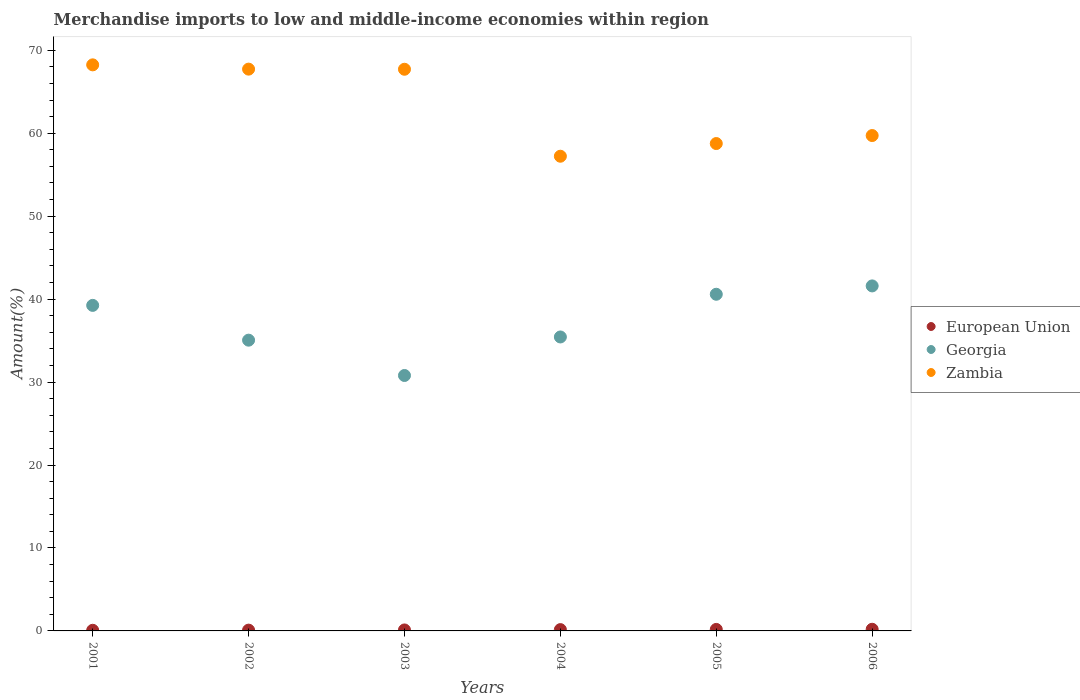Is the number of dotlines equal to the number of legend labels?
Your response must be concise. Yes. What is the percentage of amount earned from merchandise imports in Georgia in 2002?
Offer a terse response. 35.05. Across all years, what is the maximum percentage of amount earned from merchandise imports in Zambia?
Keep it short and to the point. 68.24. Across all years, what is the minimum percentage of amount earned from merchandise imports in Georgia?
Your answer should be compact. 30.79. In which year was the percentage of amount earned from merchandise imports in Georgia maximum?
Ensure brevity in your answer.  2006. What is the total percentage of amount earned from merchandise imports in European Union in the graph?
Keep it short and to the point. 0.83. What is the difference between the percentage of amount earned from merchandise imports in European Union in 2002 and that in 2004?
Provide a succinct answer. -0.06. What is the difference between the percentage of amount earned from merchandise imports in European Union in 2006 and the percentage of amount earned from merchandise imports in Zambia in 2004?
Keep it short and to the point. -57.02. What is the average percentage of amount earned from merchandise imports in Zambia per year?
Give a very brief answer. 63.23. In the year 2002, what is the difference between the percentage of amount earned from merchandise imports in Georgia and percentage of amount earned from merchandise imports in European Union?
Make the answer very short. 34.95. What is the ratio of the percentage of amount earned from merchandise imports in European Union in 2002 to that in 2005?
Offer a very short reply. 0.53. Is the difference between the percentage of amount earned from merchandise imports in Georgia in 2003 and 2005 greater than the difference between the percentage of amount earned from merchandise imports in European Union in 2003 and 2005?
Provide a short and direct response. No. What is the difference between the highest and the second highest percentage of amount earned from merchandise imports in Georgia?
Keep it short and to the point. 1.01. What is the difference between the highest and the lowest percentage of amount earned from merchandise imports in Zambia?
Give a very brief answer. 11.02. In how many years, is the percentage of amount earned from merchandise imports in European Union greater than the average percentage of amount earned from merchandise imports in European Union taken over all years?
Provide a short and direct response. 3. Is the sum of the percentage of amount earned from merchandise imports in Georgia in 2002 and 2006 greater than the maximum percentage of amount earned from merchandise imports in European Union across all years?
Make the answer very short. Yes. Is it the case that in every year, the sum of the percentage of amount earned from merchandise imports in Zambia and percentage of amount earned from merchandise imports in European Union  is greater than the percentage of amount earned from merchandise imports in Georgia?
Provide a short and direct response. Yes. How many dotlines are there?
Your answer should be very brief. 3. How many years are there in the graph?
Offer a very short reply. 6. What is the difference between two consecutive major ticks on the Y-axis?
Keep it short and to the point. 10. Does the graph contain any zero values?
Ensure brevity in your answer.  No. Does the graph contain grids?
Your response must be concise. No. How many legend labels are there?
Make the answer very short. 3. How are the legend labels stacked?
Ensure brevity in your answer.  Vertical. What is the title of the graph?
Keep it short and to the point. Merchandise imports to low and middle-income economies within region. What is the label or title of the X-axis?
Offer a terse response. Years. What is the label or title of the Y-axis?
Make the answer very short. Amount(%). What is the Amount(%) in European Union in 2001?
Offer a very short reply. 0.08. What is the Amount(%) of Georgia in 2001?
Your answer should be compact. 39.24. What is the Amount(%) in Zambia in 2001?
Make the answer very short. 68.24. What is the Amount(%) of European Union in 2002?
Ensure brevity in your answer.  0.1. What is the Amount(%) of Georgia in 2002?
Your answer should be compact. 35.05. What is the Amount(%) of Zambia in 2002?
Give a very brief answer. 67.72. What is the Amount(%) in European Union in 2003?
Make the answer very short. 0.12. What is the Amount(%) in Georgia in 2003?
Ensure brevity in your answer.  30.79. What is the Amount(%) in Zambia in 2003?
Your answer should be compact. 67.71. What is the Amount(%) of European Union in 2004?
Keep it short and to the point. 0.16. What is the Amount(%) in Georgia in 2004?
Offer a very short reply. 35.44. What is the Amount(%) of Zambia in 2004?
Provide a succinct answer. 57.22. What is the Amount(%) of European Union in 2005?
Provide a short and direct response. 0.18. What is the Amount(%) in Georgia in 2005?
Make the answer very short. 40.58. What is the Amount(%) of Zambia in 2005?
Make the answer very short. 58.75. What is the Amount(%) of European Union in 2006?
Keep it short and to the point. 0.2. What is the Amount(%) of Georgia in 2006?
Make the answer very short. 41.59. What is the Amount(%) in Zambia in 2006?
Provide a short and direct response. 59.72. Across all years, what is the maximum Amount(%) of European Union?
Give a very brief answer. 0.2. Across all years, what is the maximum Amount(%) of Georgia?
Make the answer very short. 41.59. Across all years, what is the maximum Amount(%) in Zambia?
Your answer should be compact. 68.24. Across all years, what is the minimum Amount(%) of European Union?
Keep it short and to the point. 0.08. Across all years, what is the minimum Amount(%) in Georgia?
Your response must be concise. 30.79. Across all years, what is the minimum Amount(%) in Zambia?
Keep it short and to the point. 57.22. What is the total Amount(%) of European Union in the graph?
Ensure brevity in your answer.  0.83. What is the total Amount(%) in Georgia in the graph?
Give a very brief answer. 222.69. What is the total Amount(%) of Zambia in the graph?
Offer a very short reply. 379.36. What is the difference between the Amount(%) in European Union in 2001 and that in 2002?
Offer a very short reply. -0.02. What is the difference between the Amount(%) in Georgia in 2001 and that in 2002?
Offer a terse response. 4.19. What is the difference between the Amount(%) of Zambia in 2001 and that in 2002?
Your answer should be very brief. 0.52. What is the difference between the Amount(%) in European Union in 2001 and that in 2003?
Provide a short and direct response. -0.04. What is the difference between the Amount(%) in Georgia in 2001 and that in 2003?
Provide a succinct answer. 8.45. What is the difference between the Amount(%) in Zambia in 2001 and that in 2003?
Give a very brief answer. 0.53. What is the difference between the Amount(%) in European Union in 2001 and that in 2004?
Provide a short and direct response. -0.08. What is the difference between the Amount(%) in Georgia in 2001 and that in 2004?
Provide a succinct answer. 3.81. What is the difference between the Amount(%) in Zambia in 2001 and that in 2004?
Your response must be concise. 11.02. What is the difference between the Amount(%) of European Union in 2001 and that in 2005?
Keep it short and to the point. -0.1. What is the difference between the Amount(%) of Georgia in 2001 and that in 2005?
Provide a short and direct response. -1.34. What is the difference between the Amount(%) in Zambia in 2001 and that in 2005?
Your response must be concise. 9.49. What is the difference between the Amount(%) in European Union in 2001 and that in 2006?
Ensure brevity in your answer.  -0.12. What is the difference between the Amount(%) in Georgia in 2001 and that in 2006?
Give a very brief answer. -2.35. What is the difference between the Amount(%) in Zambia in 2001 and that in 2006?
Your answer should be very brief. 8.52. What is the difference between the Amount(%) in European Union in 2002 and that in 2003?
Keep it short and to the point. -0.02. What is the difference between the Amount(%) of Georgia in 2002 and that in 2003?
Offer a very short reply. 4.26. What is the difference between the Amount(%) of Zambia in 2002 and that in 2003?
Offer a very short reply. 0.01. What is the difference between the Amount(%) of European Union in 2002 and that in 2004?
Offer a very short reply. -0.06. What is the difference between the Amount(%) of Georgia in 2002 and that in 2004?
Offer a very short reply. -0.39. What is the difference between the Amount(%) in Zambia in 2002 and that in 2004?
Your answer should be compact. 10.5. What is the difference between the Amount(%) in European Union in 2002 and that in 2005?
Offer a terse response. -0.09. What is the difference between the Amount(%) of Georgia in 2002 and that in 2005?
Your answer should be very brief. -5.53. What is the difference between the Amount(%) in Zambia in 2002 and that in 2005?
Ensure brevity in your answer.  8.97. What is the difference between the Amount(%) of European Union in 2002 and that in 2006?
Provide a short and direct response. -0.1. What is the difference between the Amount(%) in Georgia in 2002 and that in 2006?
Ensure brevity in your answer.  -6.54. What is the difference between the Amount(%) in Zambia in 2002 and that in 2006?
Make the answer very short. 8.01. What is the difference between the Amount(%) of European Union in 2003 and that in 2004?
Make the answer very short. -0.04. What is the difference between the Amount(%) in Georgia in 2003 and that in 2004?
Offer a very short reply. -4.64. What is the difference between the Amount(%) in Zambia in 2003 and that in 2004?
Provide a short and direct response. 10.48. What is the difference between the Amount(%) of European Union in 2003 and that in 2005?
Provide a succinct answer. -0.06. What is the difference between the Amount(%) of Georgia in 2003 and that in 2005?
Provide a succinct answer. -9.79. What is the difference between the Amount(%) in Zambia in 2003 and that in 2005?
Provide a short and direct response. 8.96. What is the difference between the Amount(%) in European Union in 2003 and that in 2006?
Ensure brevity in your answer.  -0.08. What is the difference between the Amount(%) in Georgia in 2003 and that in 2006?
Make the answer very short. -10.8. What is the difference between the Amount(%) of Zambia in 2003 and that in 2006?
Give a very brief answer. 7.99. What is the difference between the Amount(%) of European Union in 2004 and that in 2005?
Keep it short and to the point. -0.02. What is the difference between the Amount(%) in Georgia in 2004 and that in 2005?
Make the answer very short. -5.15. What is the difference between the Amount(%) of Zambia in 2004 and that in 2005?
Give a very brief answer. -1.53. What is the difference between the Amount(%) in European Union in 2004 and that in 2006?
Your answer should be compact. -0.04. What is the difference between the Amount(%) of Georgia in 2004 and that in 2006?
Give a very brief answer. -6.15. What is the difference between the Amount(%) in Zambia in 2004 and that in 2006?
Your response must be concise. -2.49. What is the difference between the Amount(%) of European Union in 2005 and that in 2006?
Offer a terse response. -0.02. What is the difference between the Amount(%) of Georgia in 2005 and that in 2006?
Ensure brevity in your answer.  -1.01. What is the difference between the Amount(%) in Zambia in 2005 and that in 2006?
Ensure brevity in your answer.  -0.96. What is the difference between the Amount(%) in European Union in 2001 and the Amount(%) in Georgia in 2002?
Provide a short and direct response. -34.97. What is the difference between the Amount(%) of European Union in 2001 and the Amount(%) of Zambia in 2002?
Make the answer very short. -67.65. What is the difference between the Amount(%) of Georgia in 2001 and the Amount(%) of Zambia in 2002?
Keep it short and to the point. -28.48. What is the difference between the Amount(%) of European Union in 2001 and the Amount(%) of Georgia in 2003?
Keep it short and to the point. -30.72. What is the difference between the Amount(%) of European Union in 2001 and the Amount(%) of Zambia in 2003?
Your answer should be compact. -67.63. What is the difference between the Amount(%) of Georgia in 2001 and the Amount(%) of Zambia in 2003?
Your answer should be very brief. -28.46. What is the difference between the Amount(%) of European Union in 2001 and the Amount(%) of Georgia in 2004?
Keep it short and to the point. -35.36. What is the difference between the Amount(%) of European Union in 2001 and the Amount(%) of Zambia in 2004?
Make the answer very short. -57.15. What is the difference between the Amount(%) in Georgia in 2001 and the Amount(%) in Zambia in 2004?
Provide a short and direct response. -17.98. What is the difference between the Amount(%) of European Union in 2001 and the Amount(%) of Georgia in 2005?
Your answer should be very brief. -40.51. What is the difference between the Amount(%) of European Union in 2001 and the Amount(%) of Zambia in 2005?
Offer a very short reply. -58.68. What is the difference between the Amount(%) in Georgia in 2001 and the Amount(%) in Zambia in 2005?
Provide a short and direct response. -19.51. What is the difference between the Amount(%) in European Union in 2001 and the Amount(%) in Georgia in 2006?
Offer a very short reply. -41.51. What is the difference between the Amount(%) in European Union in 2001 and the Amount(%) in Zambia in 2006?
Offer a terse response. -59.64. What is the difference between the Amount(%) in Georgia in 2001 and the Amount(%) in Zambia in 2006?
Offer a terse response. -20.47. What is the difference between the Amount(%) in European Union in 2002 and the Amount(%) in Georgia in 2003?
Your answer should be compact. -30.7. What is the difference between the Amount(%) of European Union in 2002 and the Amount(%) of Zambia in 2003?
Make the answer very short. -67.61. What is the difference between the Amount(%) of Georgia in 2002 and the Amount(%) of Zambia in 2003?
Offer a terse response. -32.66. What is the difference between the Amount(%) of European Union in 2002 and the Amount(%) of Georgia in 2004?
Make the answer very short. -35.34. What is the difference between the Amount(%) in European Union in 2002 and the Amount(%) in Zambia in 2004?
Provide a short and direct response. -57.13. What is the difference between the Amount(%) of Georgia in 2002 and the Amount(%) of Zambia in 2004?
Offer a terse response. -22.17. What is the difference between the Amount(%) of European Union in 2002 and the Amount(%) of Georgia in 2005?
Your answer should be compact. -40.49. What is the difference between the Amount(%) of European Union in 2002 and the Amount(%) of Zambia in 2005?
Your response must be concise. -58.66. What is the difference between the Amount(%) in Georgia in 2002 and the Amount(%) in Zambia in 2005?
Keep it short and to the point. -23.7. What is the difference between the Amount(%) in European Union in 2002 and the Amount(%) in Georgia in 2006?
Your answer should be compact. -41.49. What is the difference between the Amount(%) of European Union in 2002 and the Amount(%) of Zambia in 2006?
Provide a short and direct response. -59.62. What is the difference between the Amount(%) of Georgia in 2002 and the Amount(%) of Zambia in 2006?
Your answer should be very brief. -24.67. What is the difference between the Amount(%) of European Union in 2003 and the Amount(%) of Georgia in 2004?
Ensure brevity in your answer.  -35.32. What is the difference between the Amount(%) in European Union in 2003 and the Amount(%) in Zambia in 2004?
Offer a terse response. -57.11. What is the difference between the Amount(%) in Georgia in 2003 and the Amount(%) in Zambia in 2004?
Offer a terse response. -26.43. What is the difference between the Amount(%) of European Union in 2003 and the Amount(%) of Georgia in 2005?
Your response must be concise. -40.47. What is the difference between the Amount(%) in European Union in 2003 and the Amount(%) in Zambia in 2005?
Provide a short and direct response. -58.63. What is the difference between the Amount(%) in Georgia in 2003 and the Amount(%) in Zambia in 2005?
Give a very brief answer. -27.96. What is the difference between the Amount(%) of European Union in 2003 and the Amount(%) of Georgia in 2006?
Keep it short and to the point. -41.47. What is the difference between the Amount(%) of European Union in 2003 and the Amount(%) of Zambia in 2006?
Make the answer very short. -59.6. What is the difference between the Amount(%) of Georgia in 2003 and the Amount(%) of Zambia in 2006?
Ensure brevity in your answer.  -28.93. What is the difference between the Amount(%) of European Union in 2004 and the Amount(%) of Georgia in 2005?
Keep it short and to the point. -40.43. What is the difference between the Amount(%) in European Union in 2004 and the Amount(%) in Zambia in 2005?
Ensure brevity in your answer.  -58.59. What is the difference between the Amount(%) in Georgia in 2004 and the Amount(%) in Zambia in 2005?
Keep it short and to the point. -23.32. What is the difference between the Amount(%) in European Union in 2004 and the Amount(%) in Georgia in 2006?
Keep it short and to the point. -41.43. What is the difference between the Amount(%) in European Union in 2004 and the Amount(%) in Zambia in 2006?
Make the answer very short. -59.56. What is the difference between the Amount(%) in Georgia in 2004 and the Amount(%) in Zambia in 2006?
Your response must be concise. -24.28. What is the difference between the Amount(%) in European Union in 2005 and the Amount(%) in Georgia in 2006?
Your answer should be compact. -41.41. What is the difference between the Amount(%) in European Union in 2005 and the Amount(%) in Zambia in 2006?
Make the answer very short. -59.54. What is the difference between the Amount(%) of Georgia in 2005 and the Amount(%) of Zambia in 2006?
Provide a short and direct response. -19.13. What is the average Amount(%) of European Union per year?
Your answer should be very brief. 0.14. What is the average Amount(%) of Georgia per year?
Your answer should be very brief. 37.12. What is the average Amount(%) in Zambia per year?
Make the answer very short. 63.23. In the year 2001, what is the difference between the Amount(%) in European Union and Amount(%) in Georgia?
Offer a terse response. -39.17. In the year 2001, what is the difference between the Amount(%) in European Union and Amount(%) in Zambia?
Provide a short and direct response. -68.16. In the year 2001, what is the difference between the Amount(%) of Georgia and Amount(%) of Zambia?
Your answer should be compact. -29. In the year 2002, what is the difference between the Amount(%) in European Union and Amount(%) in Georgia?
Provide a succinct answer. -34.95. In the year 2002, what is the difference between the Amount(%) of European Union and Amount(%) of Zambia?
Give a very brief answer. -67.63. In the year 2002, what is the difference between the Amount(%) of Georgia and Amount(%) of Zambia?
Provide a succinct answer. -32.67. In the year 2003, what is the difference between the Amount(%) in European Union and Amount(%) in Georgia?
Offer a very short reply. -30.67. In the year 2003, what is the difference between the Amount(%) of European Union and Amount(%) of Zambia?
Provide a short and direct response. -67.59. In the year 2003, what is the difference between the Amount(%) of Georgia and Amount(%) of Zambia?
Make the answer very short. -36.92. In the year 2004, what is the difference between the Amount(%) of European Union and Amount(%) of Georgia?
Offer a terse response. -35.28. In the year 2004, what is the difference between the Amount(%) of European Union and Amount(%) of Zambia?
Ensure brevity in your answer.  -57.07. In the year 2004, what is the difference between the Amount(%) in Georgia and Amount(%) in Zambia?
Offer a very short reply. -21.79. In the year 2005, what is the difference between the Amount(%) in European Union and Amount(%) in Georgia?
Offer a very short reply. -40.4. In the year 2005, what is the difference between the Amount(%) of European Union and Amount(%) of Zambia?
Offer a very short reply. -58.57. In the year 2005, what is the difference between the Amount(%) of Georgia and Amount(%) of Zambia?
Offer a very short reply. -18.17. In the year 2006, what is the difference between the Amount(%) in European Union and Amount(%) in Georgia?
Give a very brief answer. -41.39. In the year 2006, what is the difference between the Amount(%) in European Union and Amount(%) in Zambia?
Give a very brief answer. -59.52. In the year 2006, what is the difference between the Amount(%) of Georgia and Amount(%) of Zambia?
Provide a succinct answer. -18.13. What is the ratio of the Amount(%) in European Union in 2001 to that in 2002?
Your answer should be compact. 0.8. What is the ratio of the Amount(%) of Georgia in 2001 to that in 2002?
Your answer should be compact. 1.12. What is the ratio of the Amount(%) in Zambia in 2001 to that in 2002?
Your answer should be compact. 1.01. What is the ratio of the Amount(%) of European Union in 2001 to that in 2003?
Give a very brief answer. 0.65. What is the ratio of the Amount(%) of Georgia in 2001 to that in 2003?
Make the answer very short. 1.27. What is the ratio of the Amount(%) of Zambia in 2001 to that in 2003?
Keep it short and to the point. 1.01. What is the ratio of the Amount(%) of European Union in 2001 to that in 2004?
Your answer should be compact. 0.49. What is the ratio of the Amount(%) of Georgia in 2001 to that in 2004?
Offer a very short reply. 1.11. What is the ratio of the Amount(%) of Zambia in 2001 to that in 2004?
Provide a short and direct response. 1.19. What is the ratio of the Amount(%) in European Union in 2001 to that in 2005?
Keep it short and to the point. 0.42. What is the ratio of the Amount(%) in Georgia in 2001 to that in 2005?
Give a very brief answer. 0.97. What is the ratio of the Amount(%) of Zambia in 2001 to that in 2005?
Your response must be concise. 1.16. What is the ratio of the Amount(%) of European Union in 2001 to that in 2006?
Ensure brevity in your answer.  0.38. What is the ratio of the Amount(%) of Georgia in 2001 to that in 2006?
Make the answer very short. 0.94. What is the ratio of the Amount(%) of Zambia in 2001 to that in 2006?
Offer a very short reply. 1.14. What is the ratio of the Amount(%) of European Union in 2002 to that in 2003?
Ensure brevity in your answer.  0.82. What is the ratio of the Amount(%) of Georgia in 2002 to that in 2003?
Make the answer very short. 1.14. What is the ratio of the Amount(%) in European Union in 2002 to that in 2004?
Give a very brief answer. 0.61. What is the ratio of the Amount(%) of Georgia in 2002 to that in 2004?
Give a very brief answer. 0.99. What is the ratio of the Amount(%) in Zambia in 2002 to that in 2004?
Make the answer very short. 1.18. What is the ratio of the Amount(%) of European Union in 2002 to that in 2005?
Your answer should be very brief. 0.53. What is the ratio of the Amount(%) of Georgia in 2002 to that in 2005?
Provide a short and direct response. 0.86. What is the ratio of the Amount(%) of Zambia in 2002 to that in 2005?
Your answer should be very brief. 1.15. What is the ratio of the Amount(%) of European Union in 2002 to that in 2006?
Your answer should be very brief. 0.48. What is the ratio of the Amount(%) of Georgia in 2002 to that in 2006?
Your answer should be compact. 0.84. What is the ratio of the Amount(%) in Zambia in 2002 to that in 2006?
Provide a short and direct response. 1.13. What is the ratio of the Amount(%) in European Union in 2003 to that in 2004?
Keep it short and to the point. 0.74. What is the ratio of the Amount(%) of Georgia in 2003 to that in 2004?
Keep it short and to the point. 0.87. What is the ratio of the Amount(%) in Zambia in 2003 to that in 2004?
Your response must be concise. 1.18. What is the ratio of the Amount(%) of European Union in 2003 to that in 2005?
Provide a succinct answer. 0.65. What is the ratio of the Amount(%) of Georgia in 2003 to that in 2005?
Keep it short and to the point. 0.76. What is the ratio of the Amount(%) of Zambia in 2003 to that in 2005?
Provide a short and direct response. 1.15. What is the ratio of the Amount(%) of European Union in 2003 to that in 2006?
Provide a succinct answer. 0.59. What is the ratio of the Amount(%) in Georgia in 2003 to that in 2006?
Ensure brevity in your answer.  0.74. What is the ratio of the Amount(%) in Zambia in 2003 to that in 2006?
Provide a succinct answer. 1.13. What is the ratio of the Amount(%) of European Union in 2004 to that in 2005?
Offer a very short reply. 0.87. What is the ratio of the Amount(%) of Georgia in 2004 to that in 2005?
Your answer should be very brief. 0.87. What is the ratio of the Amount(%) of Zambia in 2004 to that in 2005?
Provide a succinct answer. 0.97. What is the ratio of the Amount(%) of European Union in 2004 to that in 2006?
Provide a short and direct response. 0.79. What is the ratio of the Amount(%) of Georgia in 2004 to that in 2006?
Your answer should be very brief. 0.85. What is the ratio of the Amount(%) in European Union in 2005 to that in 2006?
Ensure brevity in your answer.  0.91. What is the ratio of the Amount(%) in Georgia in 2005 to that in 2006?
Your answer should be very brief. 0.98. What is the ratio of the Amount(%) of Zambia in 2005 to that in 2006?
Keep it short and to the point. 0.98. What is the difference between the highest and the second highest Amount(%) in European Union?
Give a very brief answer. 0.02. What is the difference between the highest and the second highest Amount(%) of Georgia?
Keep it short and to the point. 1.01. What is the difference between the highest and the second highest Amount(%) of Zambia?
Ensure brevity in your answer.  0.52. What is the difference between the highest and the lowest Amount(%) of European Union?
Make the answer very short. 0.12. What is the difference between the highest and the lowest Amount(%) in Georgia?
Give a very brief answer. 10.8. What is the difference between the highest and the lowest Amount(%) in Zambia?
Make the answer very short. 11.02. 